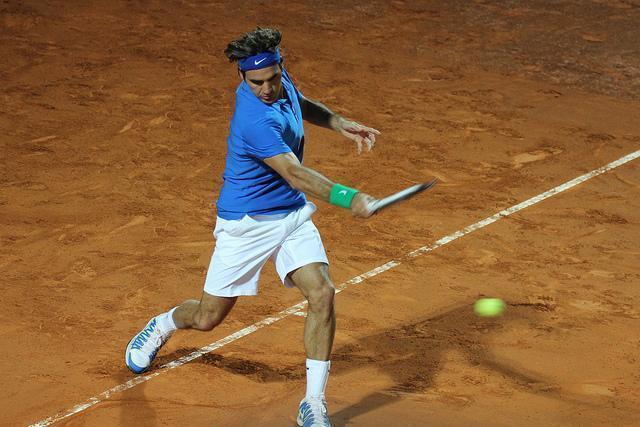What is the man wearing?
Answer the question by selecting the correct answer among the 4 following choices.
Options: Backpack, gas mask, knee brace, bandana. Bandana. 